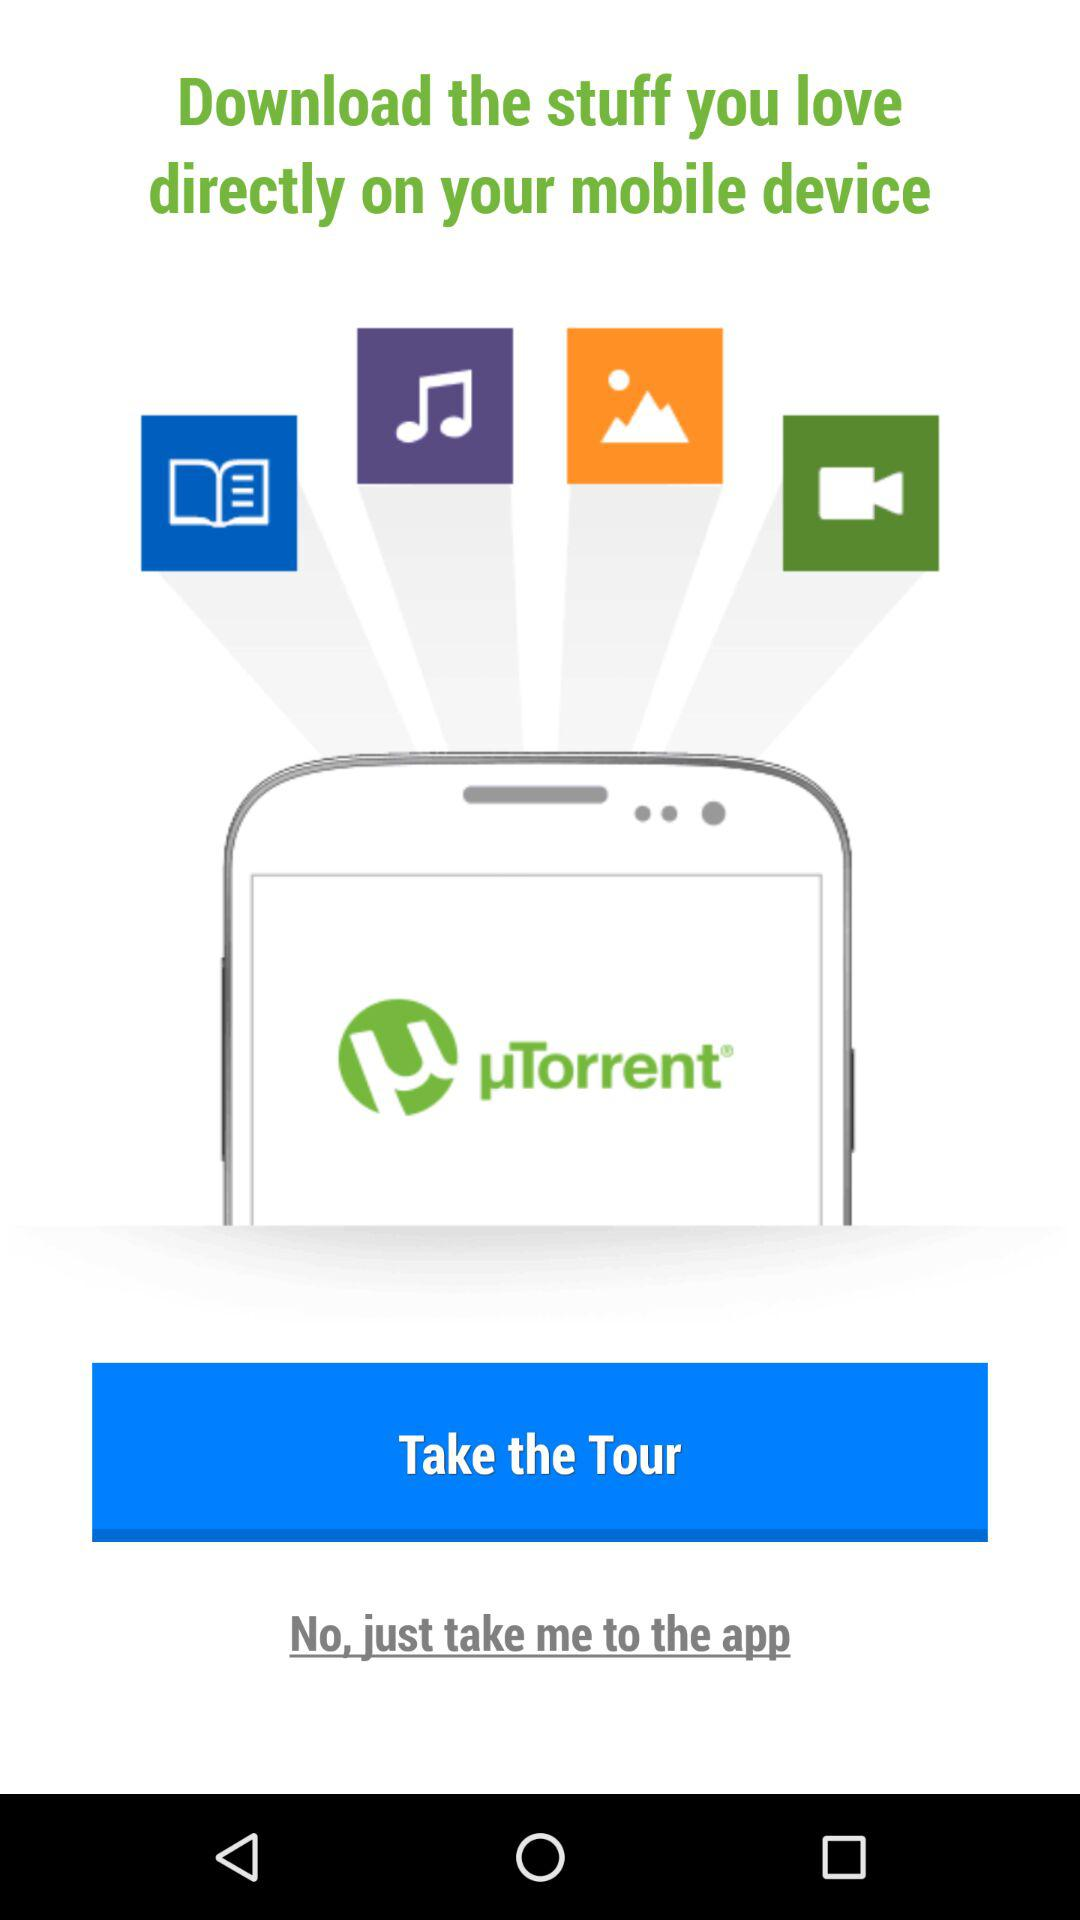What is the app name? The app name is "µTorrent". 